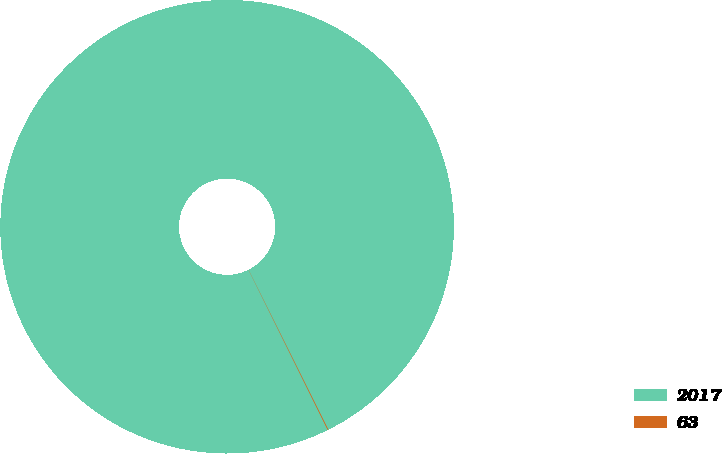Convert chart. <chart><loc_0><loc_0><loc_500><loc_500><pie_chart><fcel>2017<fcel>63<nl><fcel>99.95%<fcel>0.05%<nl></chart> 